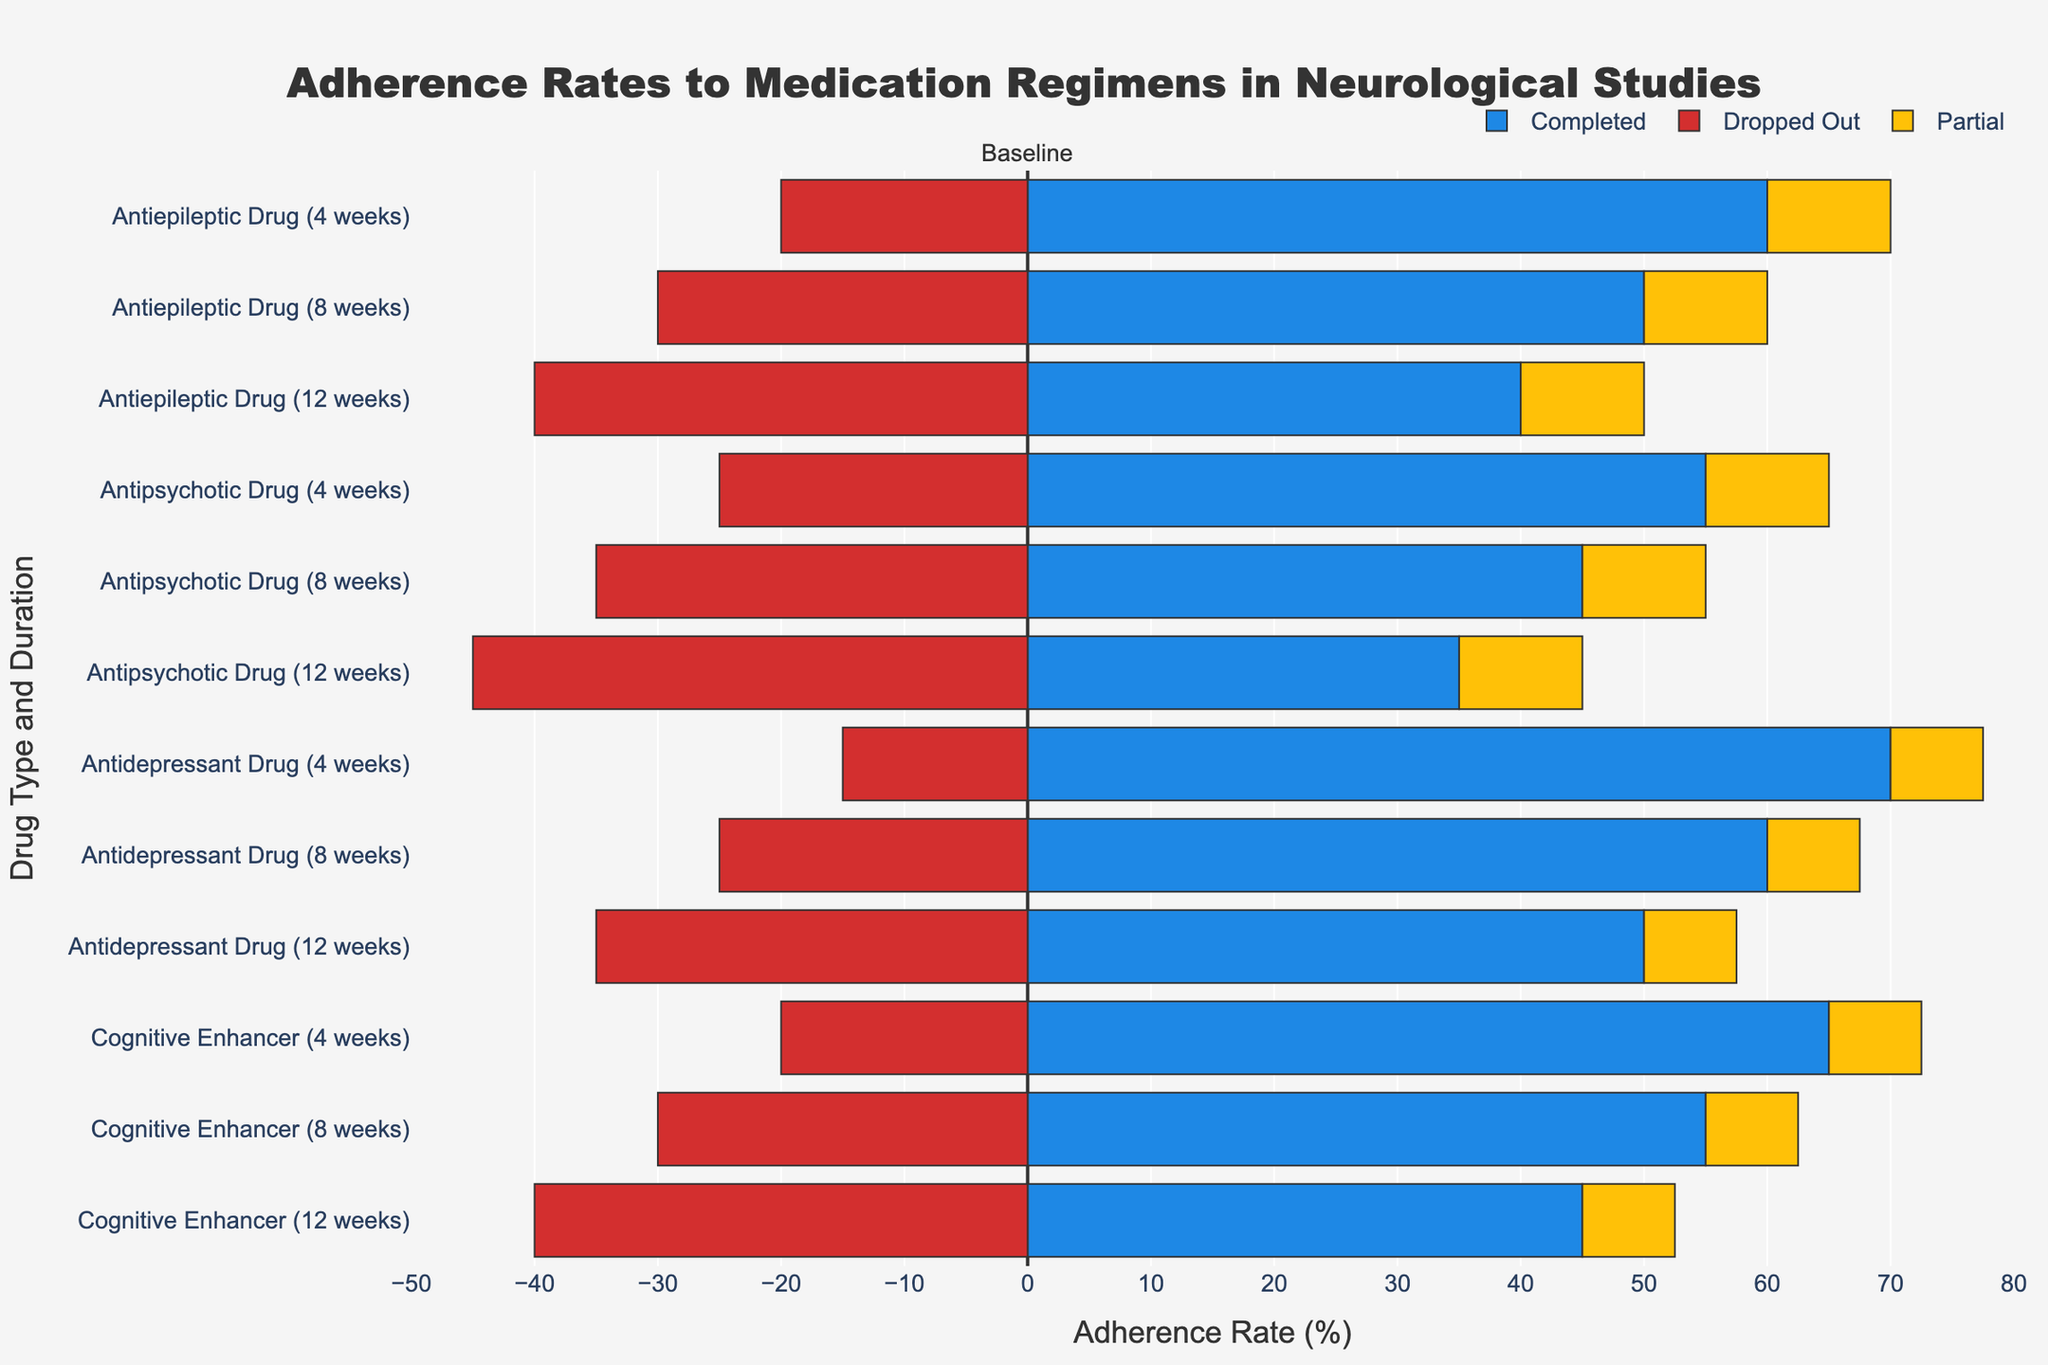What is the adherence rate for patients who completed the 12-week treatment with Antiepileptic Drugs? The adherence rate for patients who completed the 12-week treatment with Antiepileptic Drugs is represented as the rightmost segment of the bar labeled “Antiepileptic Drug (12 weeks)”. The value associated with this segment is 40%.
Answer: 40% How does the adherence rate of patients who partially adhered to the 8-week Cognitive Enhancer treatment compare to those who partially adhered to the 8-week Antidepressant Drug treatment? To compare these adherence rates, look at the lengths of the yellow segments for both drugs at 8 weeks. Both bars have the same length for the yellow segment, indicating that the adherence rate is the same for both, which is 15%.
Answer: Equal Which drug type and duration had the highest dropped-out rate? Identify the drug type and treatment duration with the longest red bar extending in the negative direction. The longest red bar is associated with the Antipsychotic Drug for 12 weeks, having a dropped-out rate of 45%.
Answer: Antipsychotic Drug (12 weeks) What is the combined rate of dropped out and partially adhered for the 12-week Antidepressant Drug treatment? First, the dropped out rate is -35% (converted to positive) and the partially adhered rate is 15%. Summing these values gives the combined rate: 35% + 15% = 50%.
Answer: 50% Which drug type has the highest adherence rate (completed) consistently across all durations? Examine the rightmost blue segments across all durations for each drug. The Antidepressant Drug consistently has the highest adherence rate (completed) over 4 weeks (70%), 8 weeks (60%), and 12 weeks (50%) compared to other drugs.
Answer: Antidepressant Drug Compare the adherence rate (completed) between the 4-week treatment with Cognitive Enhancer and the 8-week treatment with Antipsychotic Drug. Look at the blue segments for both the 4-week Cognitive Enhancer and 8-week Antipsychotic Drug. The 4-week Cognitive Enhancer has 65%, while the 8-week Antipsychotic Drug has 45%. Thus, the 4-week Cognitive Enhancer has a higher adherence rate.
Answer: 4-week Cognitive Enhancer Is there any drug type and duration where the adherence rates (completed, dropped out, and partial) are balanced equally? An equal balance would mean all three rates are equal. Review each bar for equality in blue, red, and yellow segments. No drug type and duration have all three segments equal.
Answer: None Calculate the average adherence rate for patients completing treatment across all durations for Antipsychotic Drugs. Adherence completion rates for Antipsychotic Drugs are 55% (4 weeks), 45% (8 weeks), and 35% (12 weeks). Summing these rates: 55% + 45% + 35% = 135%. Then, divide by 3 (number of durations): 135% / 3 = 45%.
Answer: 45% Which drug and duration have the shortest bar representing the dropped-out rate? Identify the bar with the shortest red segment indicating the lowest dropped-out rate. The 4-week Antidepressant Drug has the shortest red segment with a dropped-out rate of 15%.
Answer: 4-week Antidepressant Drug How does the dropped-out rate for 12-week Cognitive Enhancer compare to the 12-week Antiepileptic Drug? Compare the lengths of the red segments of the respective bars. The 12-week Cognitive Enhancer has a dropped-out rate of 40%, while the 12-week Antiepileptic Drug also has a dropped-out rate of 40%. They are equal.
Answer: Equal 